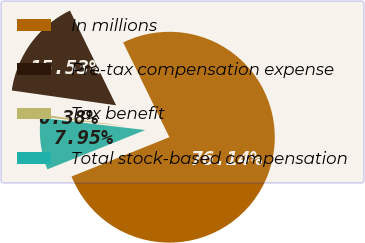Convert chart. <chart><loc_0><loc_0><loc_500><loc_500><pie_chart><fcel>In millions<fcel>Pre-tax compensation expense<fcel>Tax benefit<fcel>Total stock-based compensation<nl><fcel>76.14%<fcel>15.53%<fcel>0.38%<fcel>7.95%<nl></chart> 